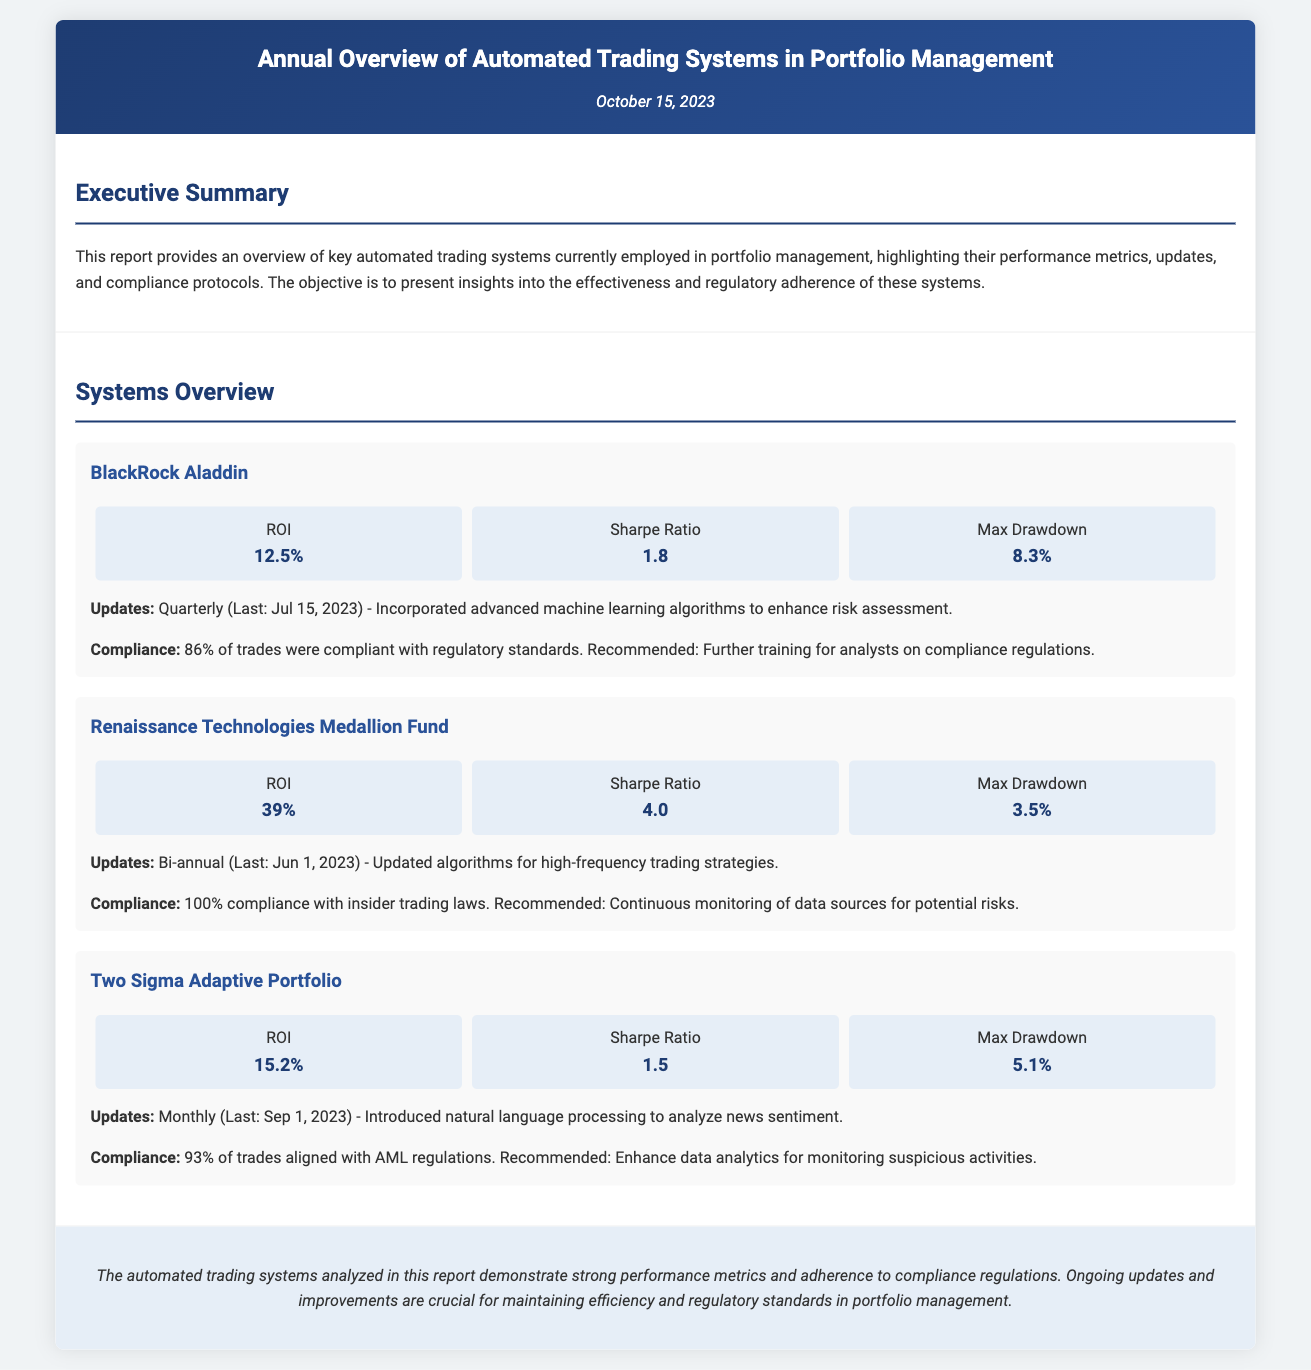What is the report date? The report date is mentioned at the top of the document in the header section.
Answer: October 15, 2023 What is the ROI of Renaissance Technologies Medallion Fund? The ROI figure can be found in the performance metrics for the Renaissance Technologies Medallion Fund section.
Answer: 39% What update was made to Two Sigma Adaptive Portfolio last? This information is provided in the updates section for Two Sigma Adaptive Portfolio.
Answer: Introduced natural language processing to analyze news sentiment What is the Sharpe Ratio of BlackRock Aladdin? The Sharpe Ratio is listed in the performance metrics for BlackRock Aladdin in the systems overview section.
Answer: 1.8 What percentage of trades from Two Sigma Adaptive Portfolio complied with AML regulations? This figure is specified in the compliance section for Two Sigma Adaptive Portfolio.
Answer: 93% Which automated trading system showed the highest Max Drawdown? This information requires comparing the Max Drawdown figures for each system in the document.
Answer: BlackRock Aladdin What compliance issue was recommended for BlackRock Aladdin? The recommendation related to compliance for BlackRock Aladdin can be found in its compliance section.
Answer: Further training for analysts on compliance regulations What is the last update date for Renaissance Technologies Medallion Fund? The last update date is mentioned in the updates section for Renaissance Technologies Medallion Fund.
Answer: June 1, 2023 What is the main focus of the executive summary? The executive summary provides a broad overview of the content and purpose of the report.
Answer: Key automated trading systems, performance metrics, updates, and compliance protocols 